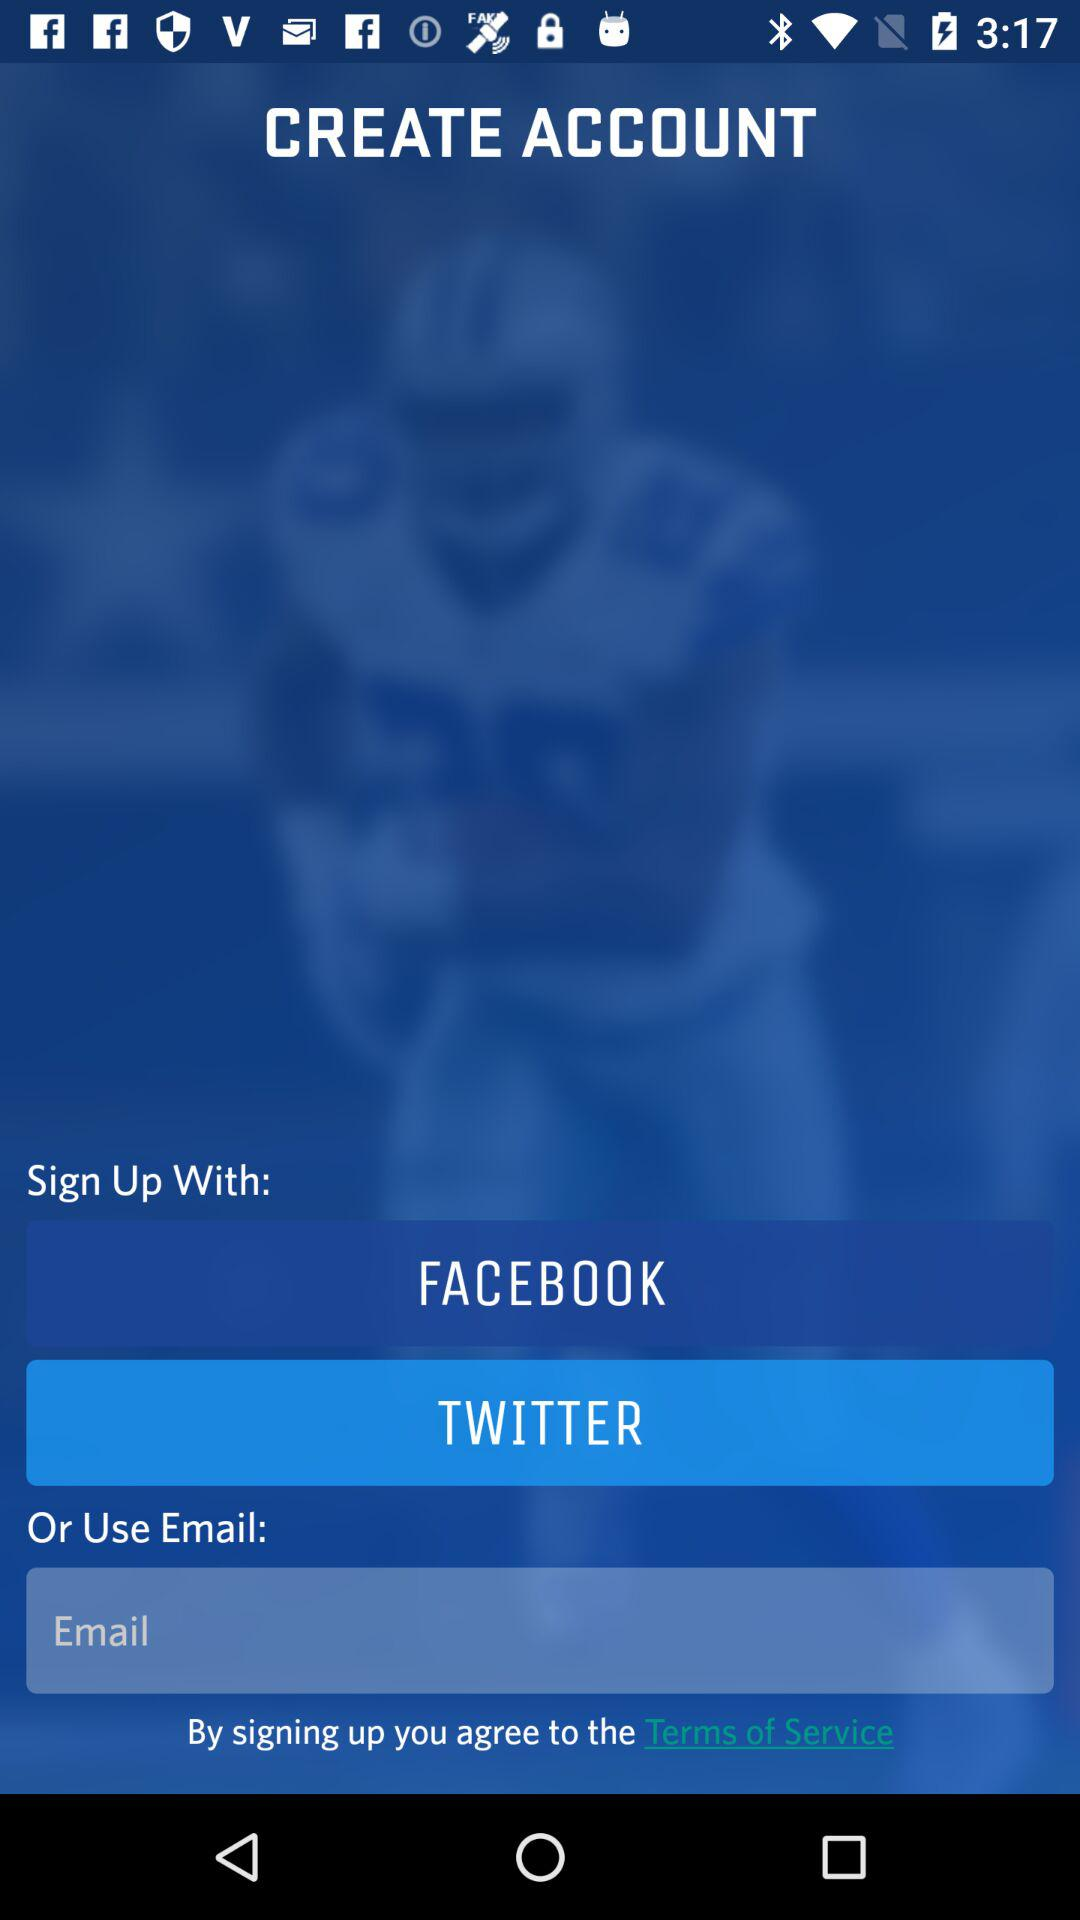How many social media platforms can I sign up with?
Answer the question using a single word or phrase. 2 